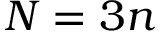Convert formula to latex. <formula><loc_0><loc_0><loc_500><loc_500>N = 3 n</formula> 